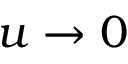Convert formula to latex. <formula><loc_0><loc_0><loc_500><loc_500>u \rightarrow 0</formula> 